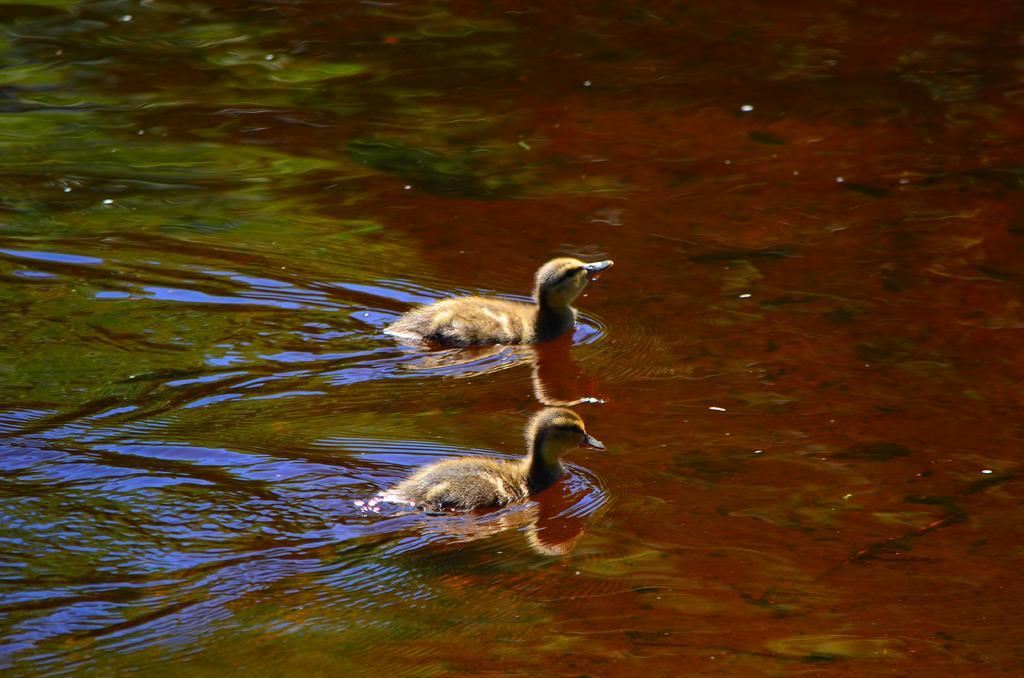What animals are present in the image? There are two ducks in the image. Where are the ducks located in the image? The ducks are in the center of the image. What are the ducks doing in the image? The ducks are swimming in the water. How many robins can be seen flying in the image? There are no robins present in the image; it features two ducks. Are there any toys visible in the image? There is no toy present in the image. 